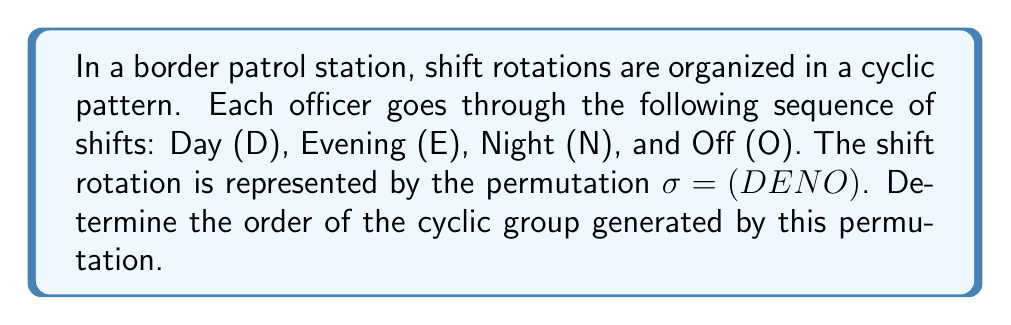Could you help me with this problem? To solve this problem, we need to understand the concept of cyclic groups and permutation order:

1) The permutation $\sigma = (DENO)$ represents a cycle of length 4.

2) In general, for a cycle of length $n$, the order of the permutation (and the cyclic group it generates) is equal to $n$.

3) This is because applying the permutation $n$ times will bring every element back to its original position.

4) In this case, we have:
   $\sigma^1 = (DENO)$
   $\sigma^2 = (DNOE)$
   $\sigma^3 = (DOEN)$
   $\sigma^4 = (DENO)$

5) We can see that $\sigma^4 = \sigma^0 = e$ (the identity permutation), where each officer is back to their original shift.

6) Therefore, the smallest positive integer $k$ such that $\sigma^k = e$ is 4.

7) This means that the order of the permutation $\sigma$, and consequently the order of the cyclic group $\langle \sigma \rangle$ it generates, is 4.

This cyclic group represents the full rotation cycle of shifts that each border patrol officer goes through before returning to their original shift.
Answer: The order of the cyclic group representing the border patrol shift rotations is 4. 